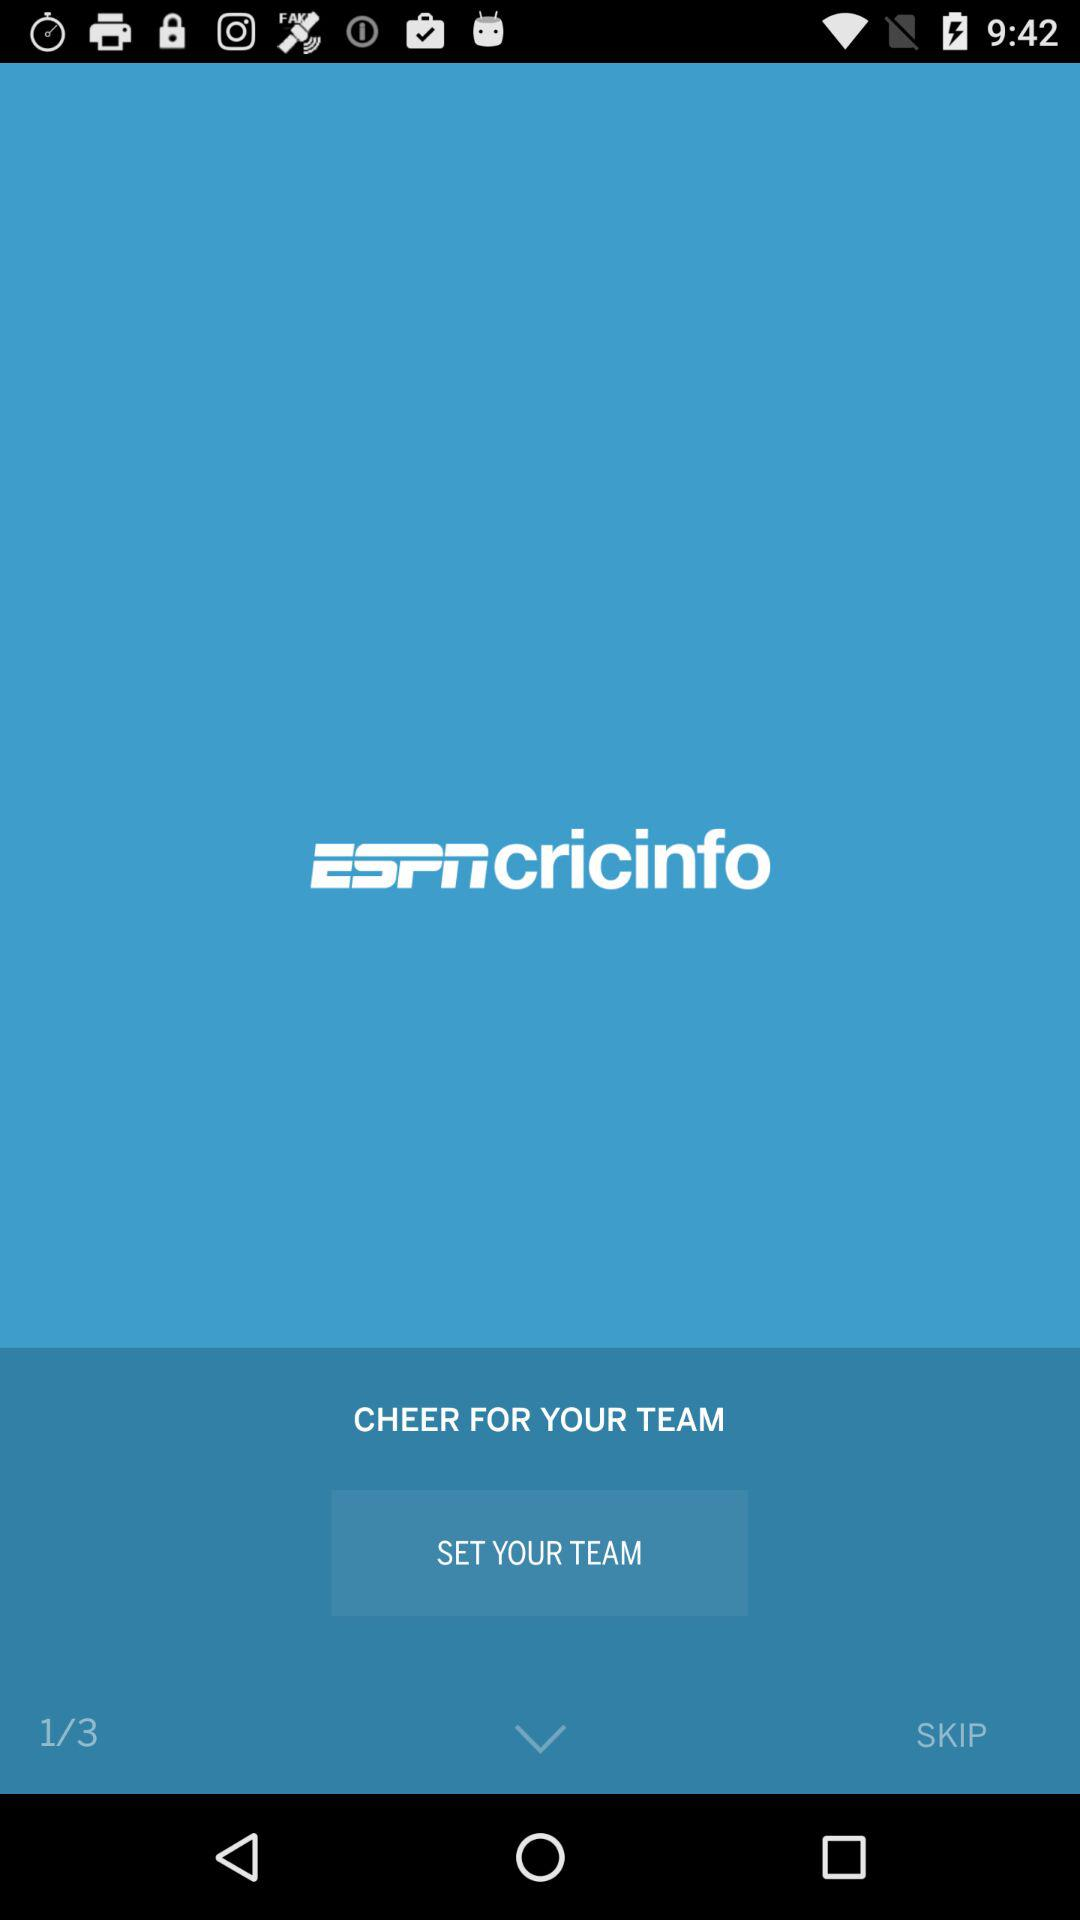How many total steps are there?
Answer the question using a single word or phrase. There are 3 total steps 